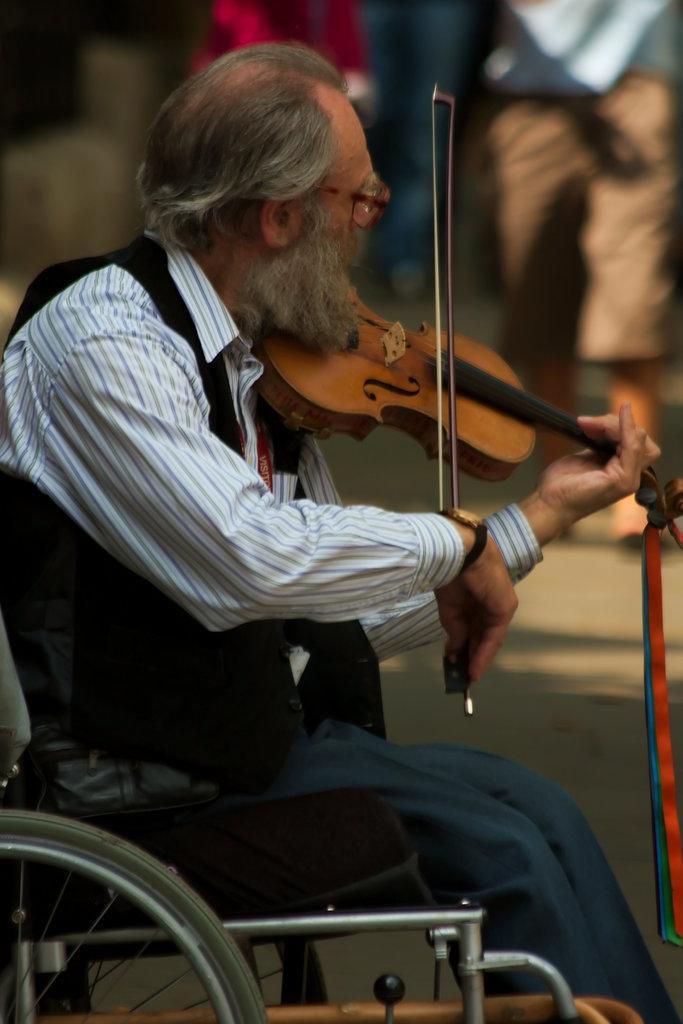Please provide a concise description of this image. In this picture we have a person sitting in the wheelchair and playing a violin. 